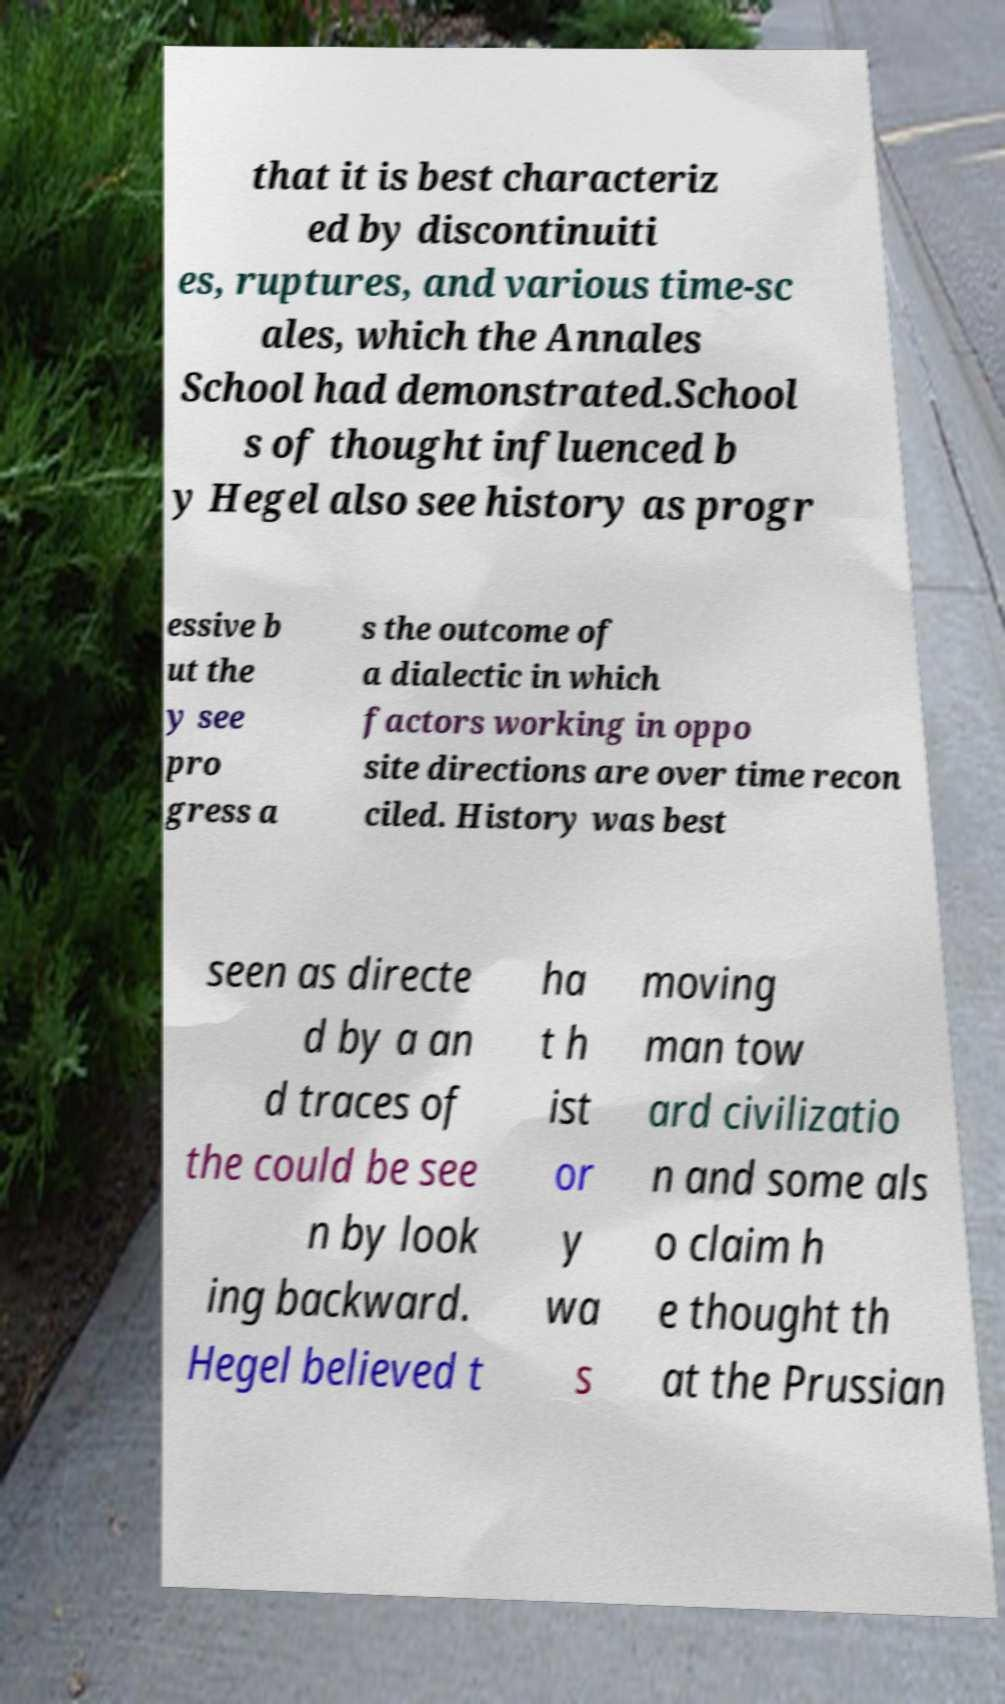For documentation purposes, I need the text within this image transcribed. Could you provide that? that it is best characteriz ed by discontinuiti es, ruptures, and various time-sc ales, which the Annales School had demonstrated.School s of thought influenced b y Hegel also see history as progr essive b ut the y see pro gress a s the outcome of a dialectic in which factors working in oppo site directions are over time recon ciled. History was best seen as directe d by a an d traces of the could be see n by look ing backward. Hegel believed t ha t h ist or y wa s moving man tow ard civilizatio n and some als o claim h e thought th at the Prussian 